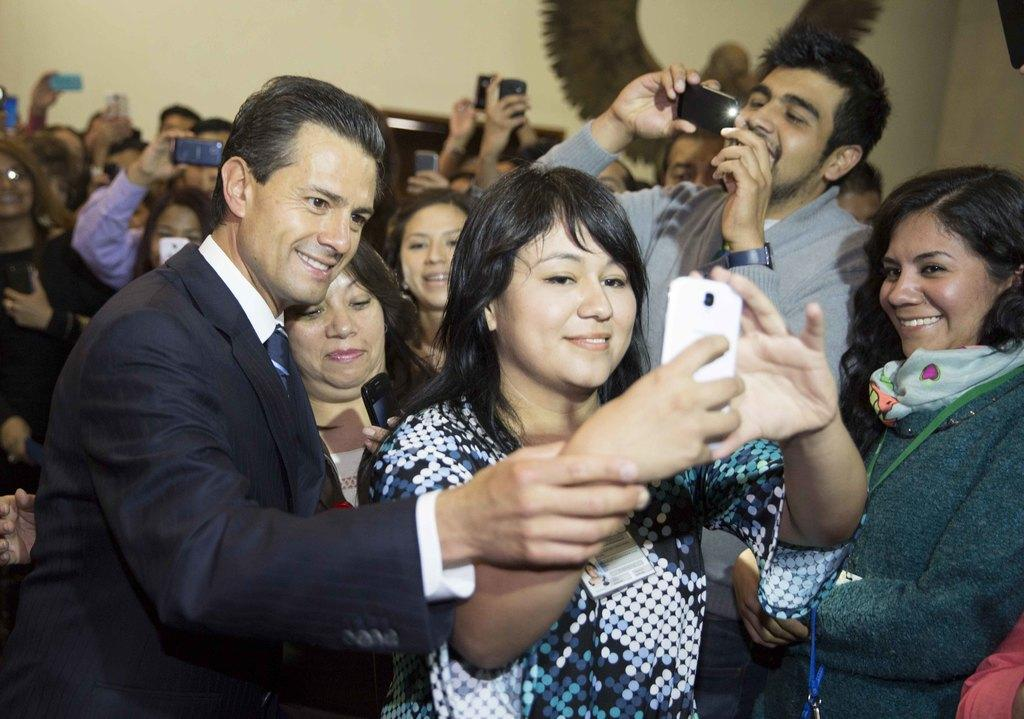What are the people in the image doing? The persons in the image are standing and taking snaps with their phones. What are the people wearing in the image? The persons in the image are wearing clothes. What type of watch can be seen on the person's wrist in the image? There is no watch visible on any person's wrist in the image. What kind of art is being created by the persons in the image? The persons in the image are not creating any art; they are taking snaps with their phones. 